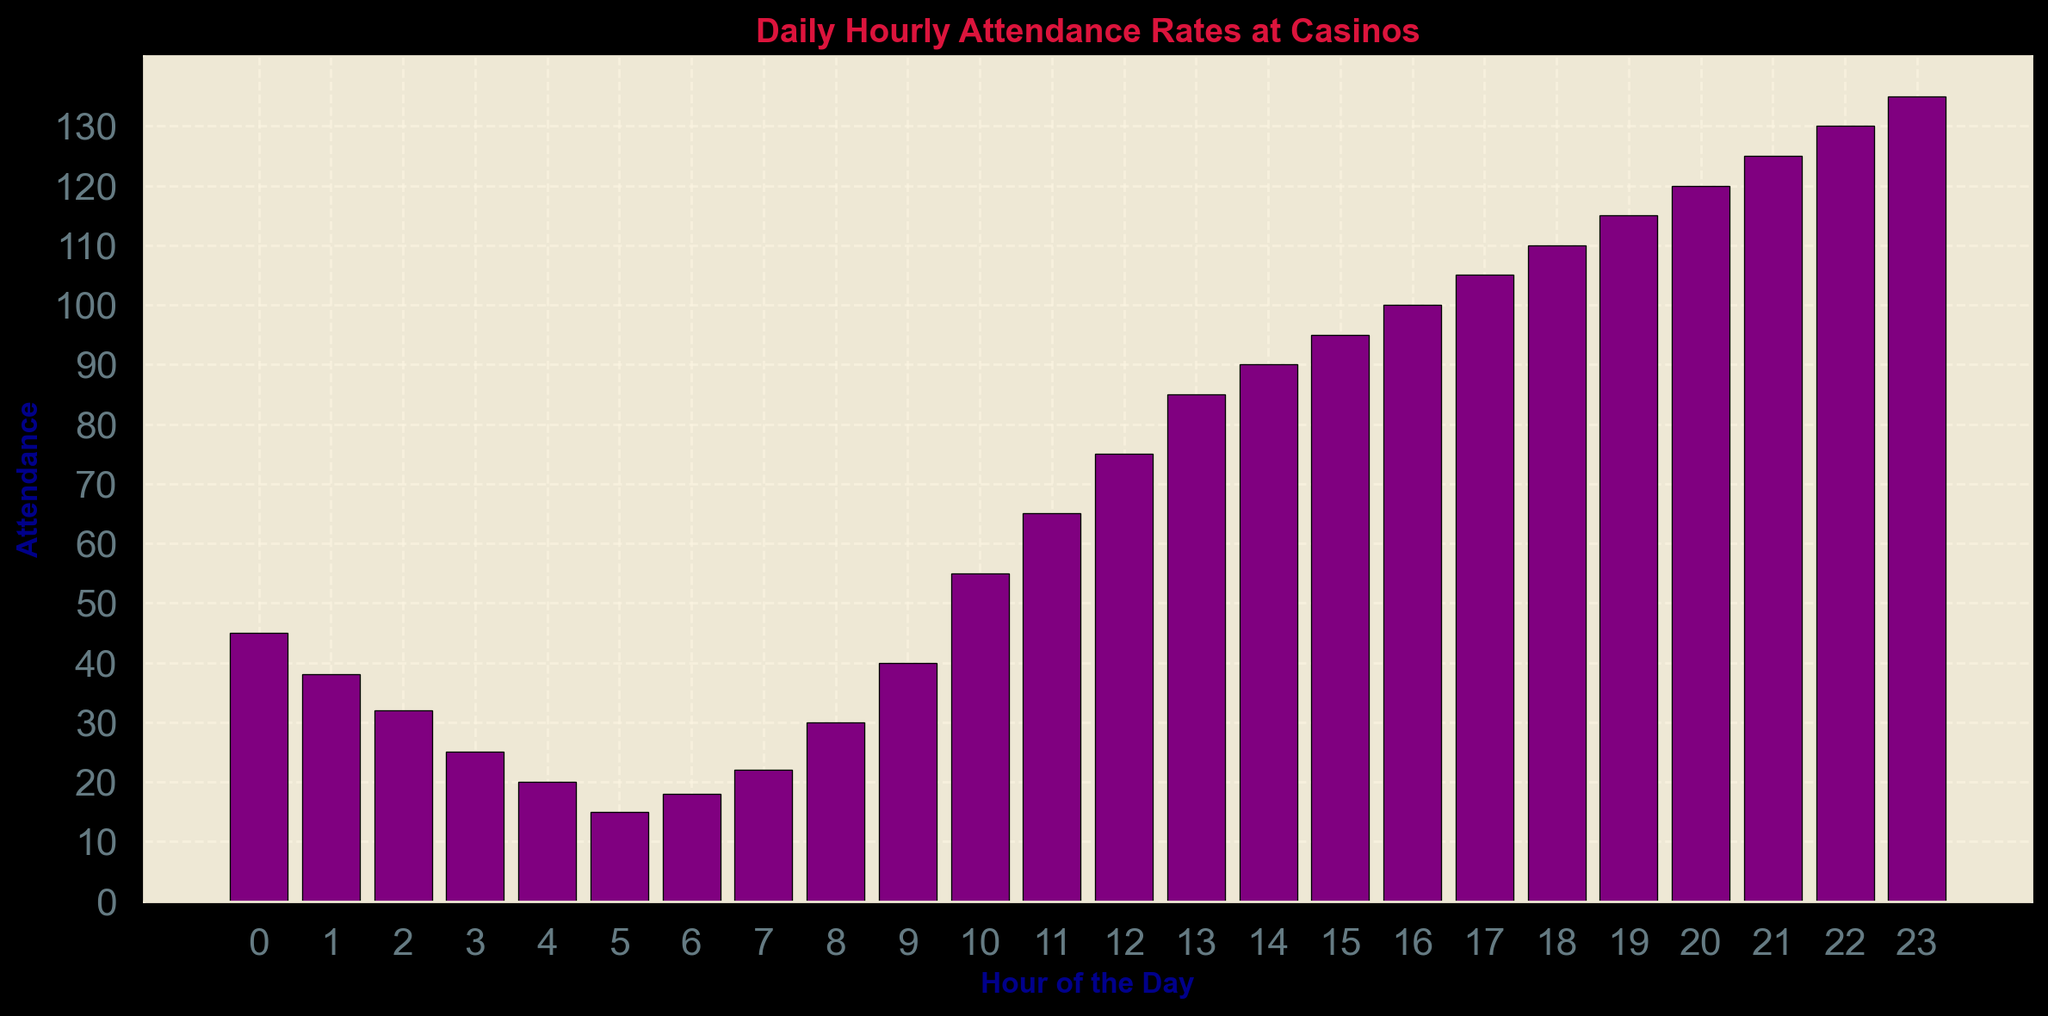What is the attendance at 8 AM? To find the attendance at 8 AM, look for the bar representing the 8th hour in the plot, then refer to the height of the bar which corresponds to the attendance number.
Answer: 30 Which hour has the highest attendance? To determine the hour with the highest attendance, scan all the bars to find the one with the maximum height. The highest bar indicates the hour with the highest attendance.
Answer: 11 PM What is the difference in attendance between 2 PM and 10 AM? Find the attendance values for 2 PM (90) and 10 AM (55), then subtract the value at 10 AM from the value at 2 PM: 90 - 55 = 35.
Answer: 35 During which hour is the attendance exactly 100? Look for the bar that has a height corresponding to the value 100.
Answer: 4 PM What is the average attendance between 6 PM and 9 PM? Determine the attendance values for 6 PM (110), 7 PM (115), 8 PM (120), and 9 PM (125), then calculate the average: (110 + 115 + 120 + 125) / 4 = 117.5.
Answer: 117.5 Is the attendance at 7 AM greater than the attendance at 5 AM? Compare the bar heights or values for 7 AM (22) and 5 AM (15); since 22 is greater than 15, the attendance at 7 AM is greater.
Answer: Yes What is the median attendance value for the hours between 12 PM and 6 PM? First, list the attendance values for 12 PM to 6 PM: 75, 85, 90, 95, 100, 105. Since there is an even number of values, the median is the average of the middle two values (90 and 95): (90 + 95) / 2 = 92.5.
Answer: 92.5 How many hours have an attendance of less than 50? Count the number of bars with a height that corresponds to an attendance of less than 50. These hours are 0 AM, 1 AM, 2 AM, 3 AM, 4 AM, 5 AM, 6 AM, and 7 AM. Therefore, there are 8 hours.
Answer: 8 At what time does the attendance first reach 100? Look for the first bar that reaches an attendance value of 100. This occurs at 4 PM.
Answer: 4 PM 